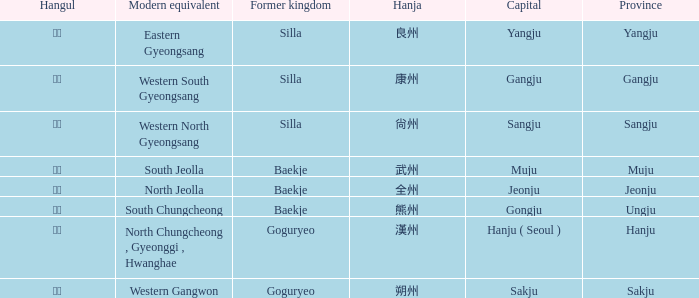What is the hanja for the province of "sangju"? 尙州. 